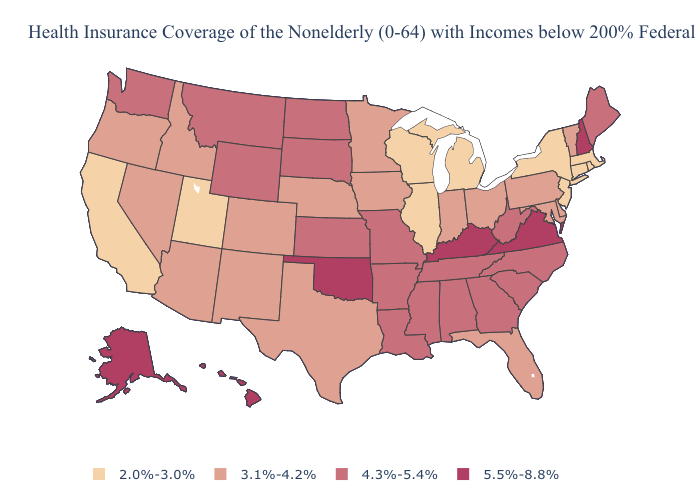Does the first symbol in the legend represent the smallest category?
Be succinct. Yes. Among the states that border Louisiana , which have the highest value?
Keep it brief. Arkansas, Mississippi. What is the value of Idaho?
Quick response, please. 3.1%-4.2%. Does Indiana have the lowest value in the MidWest?
Write a very short answer. No. What is the lowest value in the Northeast?
Keep it brief. 2.0%-3.0%. Among the states that border South Dakota , does Nebraska have the lowest value?
Concise answer only. Yes. Among the states that border Kansas , does Colorado have the highest value?
Be succinct. No. Does New Hampshire have a lower value than Mississippi?
Keep it brief. No. Does Idaho have a lower value than Alaska?
Answer briefly. Yes. How many symbols are there in the legend?
Short answer required. 4. How many symbols are there in the legend?
Short answer required. 4. What is the lowest value in states that border Washington?
Write a very short answer. 3.1%-4.2%. Does Maine have the lowest value in the Northeast?
Short answer required. No. Which states have the lowest value in the MidWest?
Quick response, please. Illinois, Michigan, Wisconsin. Name the states that have a value in the range 4.3%-5.4%?
Answer briefly. Alabama, Arkansas, Georgia, Kansas, Louisiana, Maine, Mississippi, Missouri, Montana, North Carolina, North Dakota, South Carolina, South Dakota, Tennessee, Washington, West Virginia, Wyoming. 